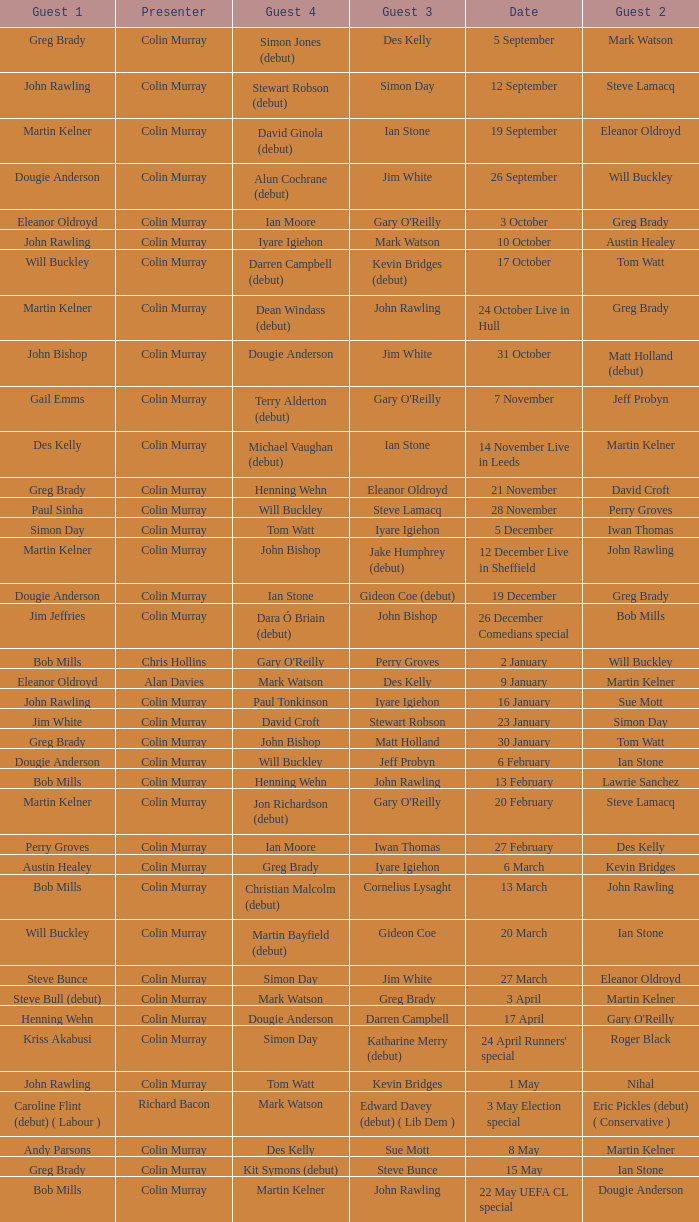How many people are guest 1 on episodes where guest 4 is Des Kelly? 1.0. 